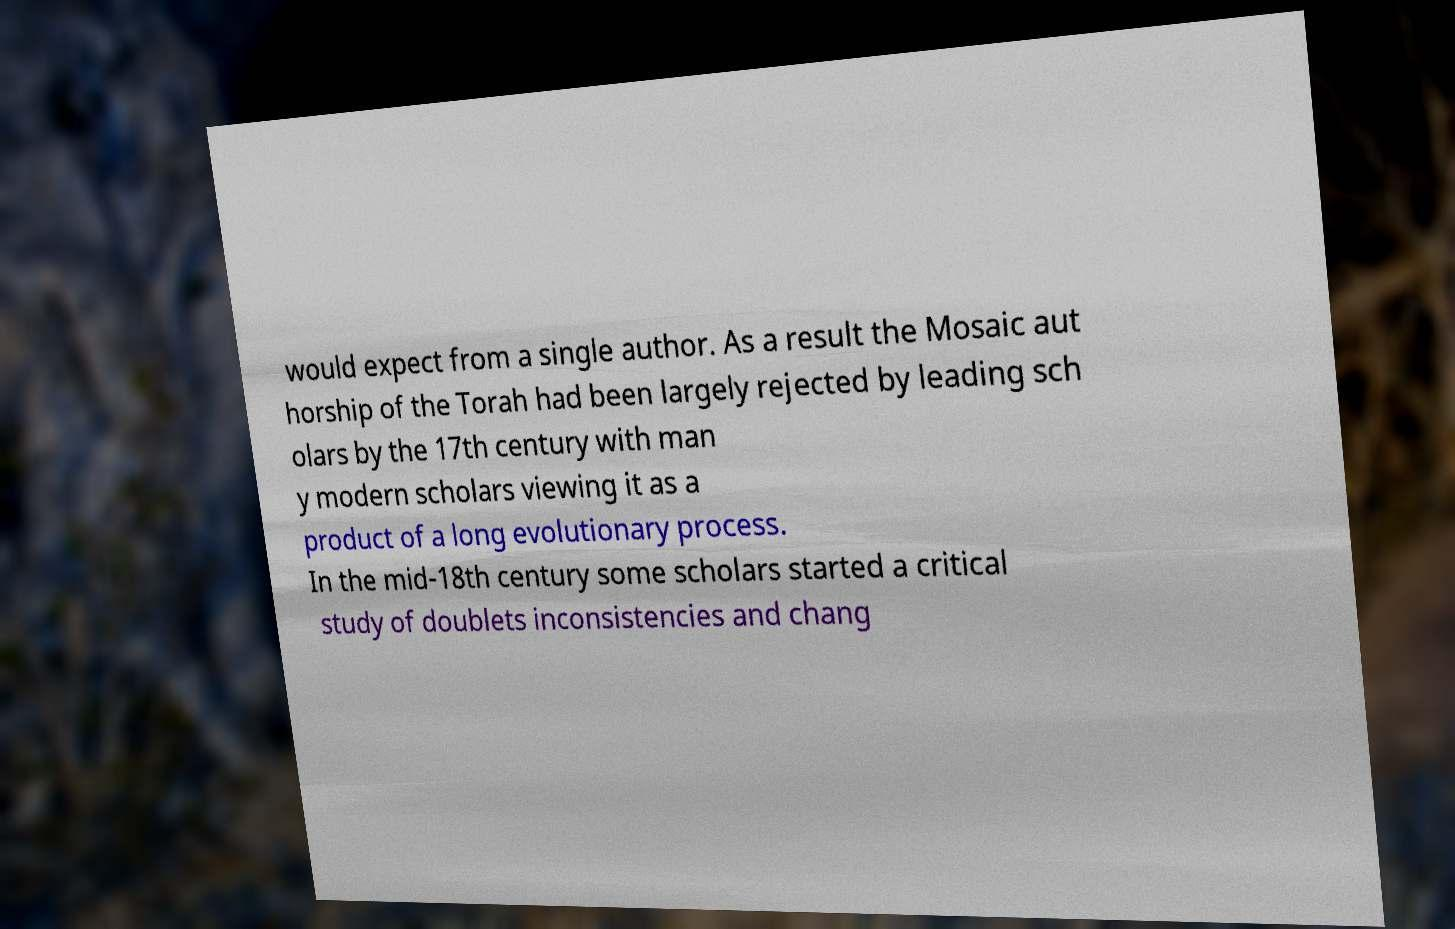Can you read and provide the text displayed in the image?This photo seems to have some interesting text. Can you extract and type it out for me? would expect from a single author. As a result the Mosaic aut horship of the Torah had been largely rejected by leading sch olars by the 17th century with man y modern scholars viewing it as a product of a long evolutionary process. In the mid-18th century some scholars started a critical study of doublets inconsistencies and chang 